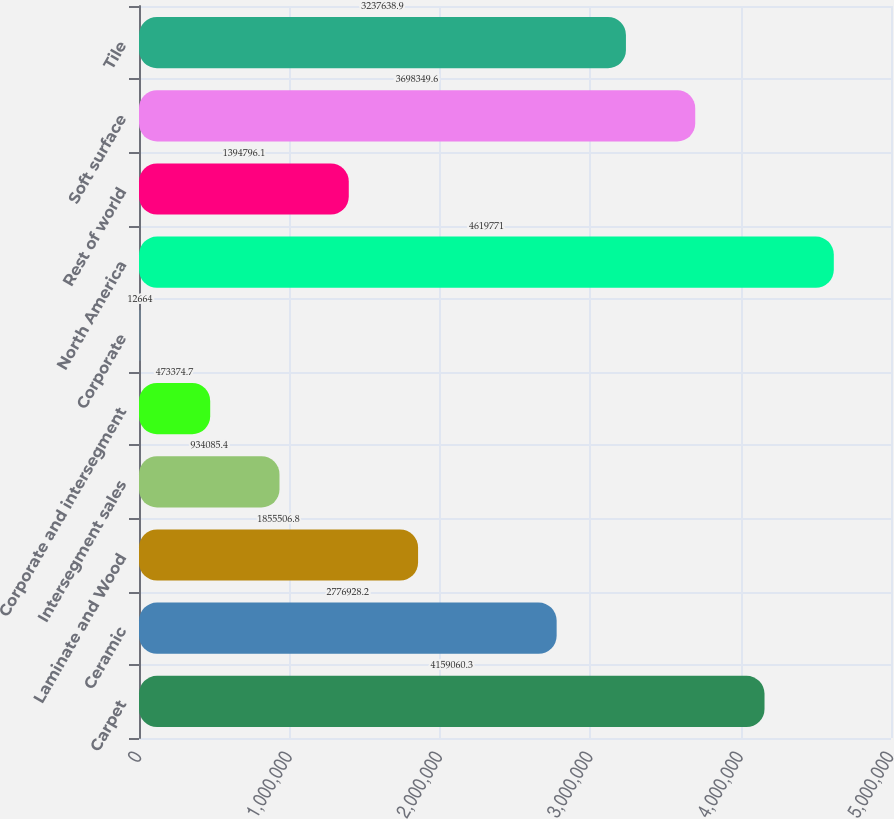Convert chart. <chart><loc_0><loc_0><loc_500><loc_500><bar_chart><fcel>Carpet<fcel>Ceramic<fcel>Laminate and Wood<fcel>Intersegment sales<fcel>Corporate and intersegment<fcel>Corporate<fcel>North America<fcel>Rest of world<fcel>Soft surface<fcel>Tile<nl><fcel>4.15906e+06<fcel>2.77693e+06<fcel>1.85551e+06<fcel>934085<fcel>473375<fcel>12664<fcel>4.61977e+06<fcel>1.3948e+06<fcel>3.69835e+06<fcel>3.23764e+06<nl></chart> 